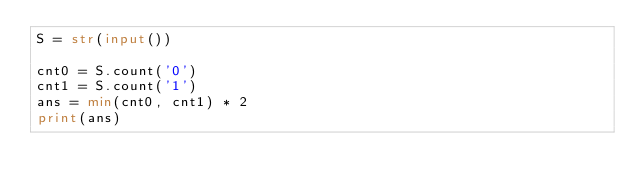Convert code to text. <code><loc_0><loc_0><loc_500><loc_500><_Python_>S = str(input())

cnt0 = S.count('0')
cnt1 = S.count('1')
ans = min(cnt0, cnt1) * 2
print(ans)</code> 